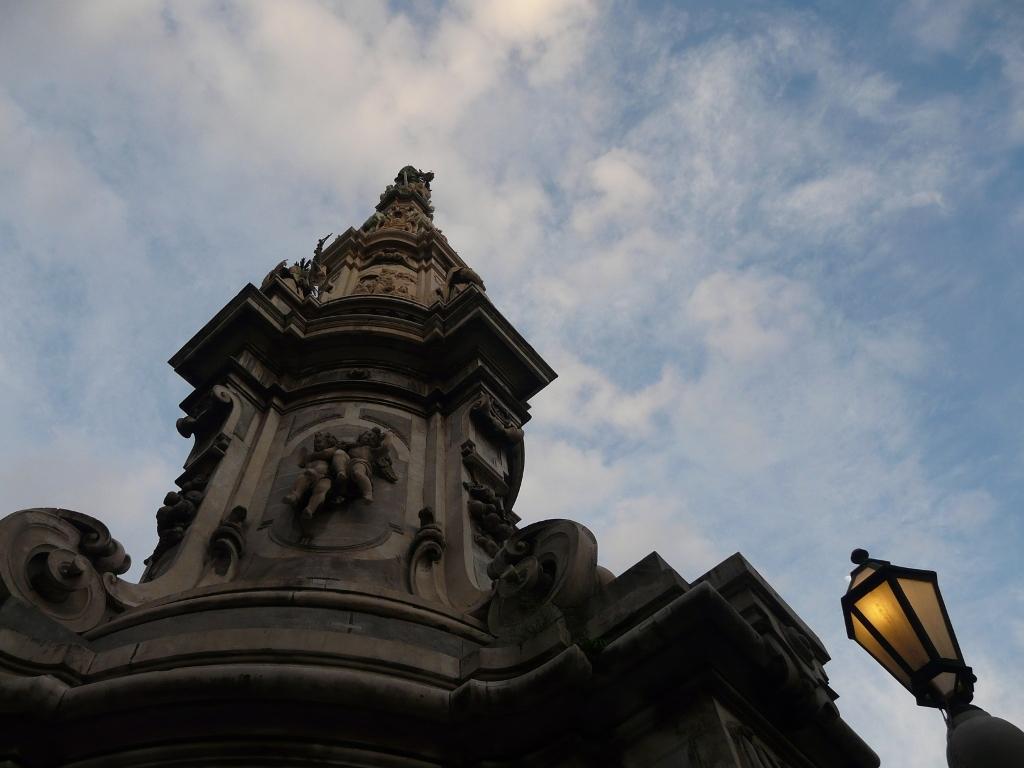Describe this image in one or two sentences. This is a picture of a building with sculptures, light , and in the background there is sky. 